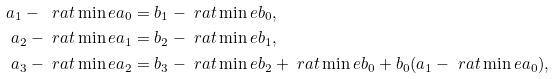Convert formula to latex. <formula><loc_0><loc_0><loc_500><loc_500>a _ { 1 } - \ r a t \min { e } a _ { 0 } & = b _ { 1 } - \ r a t \min { e } b _ { 0 } , \\ a _ { 2 } - \ r a t \min { e } a _ { 1 } & = b _ { 2 } - \ r a t \min { e } b _ { 1 } , \\ a _ { 3 } - \ r a t \min { e } a _ { 2 } & = b _ { 3 } - \ r a t \min { e } b _ { 2 } + \ r a t \min { e } b _ { 0 } + b _ { 0 } ( a _ { 1 } - \ r a t \min { e } a _ { 0 } ) ,</formula> 